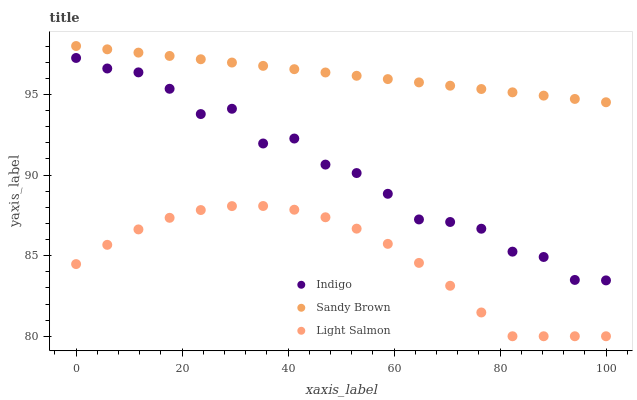Does Light Salmon have the minimum area under the curve?
Answer yes or no. Yes. Does Sandy Brown have the maximum area under the curve?
Answer yes or no. Yes. Does Indigo have the minimum area under the curve?
Answer yes or no. No. Does Indigo have the maximum area under the curve?
Answer yes or no. No. Is Sandy Brown the smoothest?
Answer yes or no. Yes. Is Indigo the roughest?
Answer yes or no. Yes. Is Light Salmon the smoothest?
Answer yes or no. No. Is Light Salmon the roughest?
Answer yes or no. No. Does Light Salmon have the lowest value?
Answer yes or no. Yes. Does Indigo have the lowest value?
Answer yes or no. No. Does Sandy Brown have the highest value?
Answer yes or no. Yes. Does Indigo have the highest value?
Answer yes or no. No. Is Light Salmon less than Indigo?
Answer yes or no. Yes. Is Indigo greater than Light Salmon?
Answer yes or no. Yes. Does Light Salmon intersect Indigo?
Answer yes or no. No. 